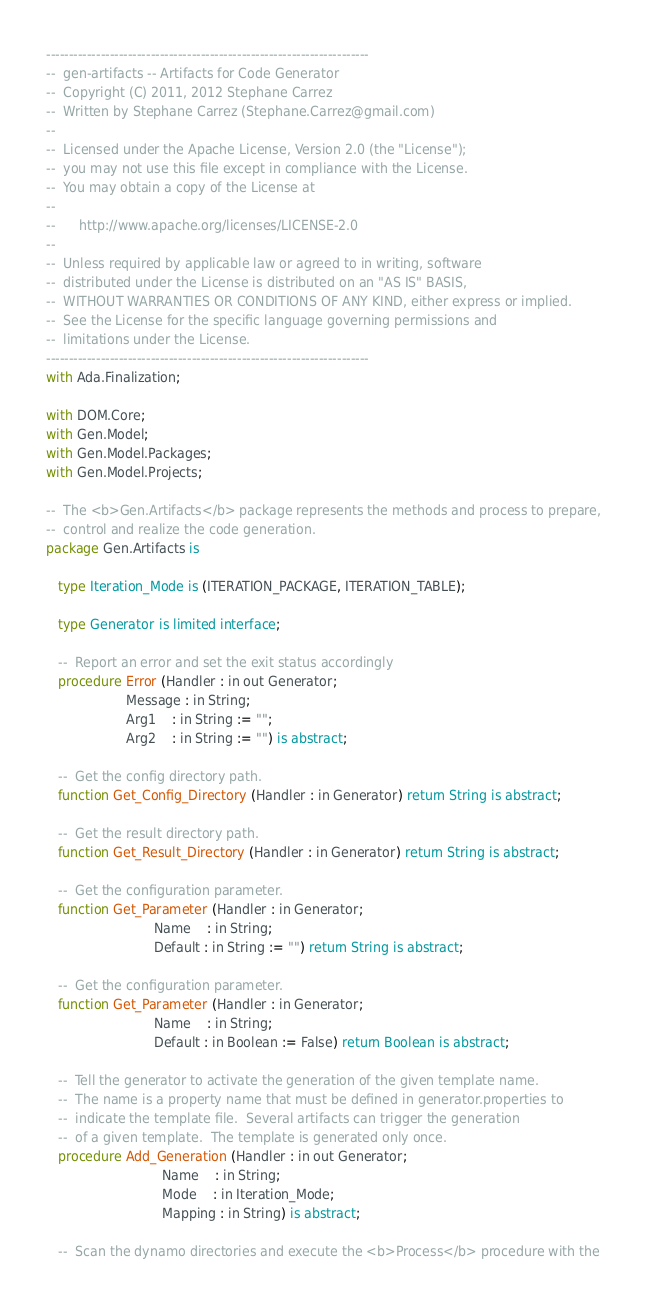<code> <loc_0><loc_0><loc_500><loc_500><_Ada_>-----------------------------------------------------------------------
--  gen-artifacts -- Artifacts for Code Generator
--  Copyright (C) 2011, 2012 Stephane Carrez
--  Written by Stephane Carrez (Stephane.Carrez@gmail.com)
--
--  Licensed under the Apache License, Version 2.0 (the "License");
--  you may not use this file except in compliance with the License.
--  You may obtain a copy of the License at
--
--      http://www.apache.org/licenses/LICENSE-2.0
--
--  Unless required by applicable law or agreed to in writing, software
--  distributed under the License is distributed on an "AS IS" BASIS,
--  WITHOUT WARRANTIES OR CONDITIONS OF ANY KIND, either express or implied.
--  See the License for the specific language governing permissions and
--  limitations under the License.
-----------------------------------------------------------------------
with Ada.Finalization;

with DOM.Core;
with Gen.Model;
with Gen.Model.Packages;
with Gen.Model.Projects;

--  The <b>Gen.Artifacts</b> package represents the methods and process to prepare,
--  control and realize the code generation.
package Gen.Artifacts is

   type Iteration_Mode is (ITERATION_PACKAGE, ITERATION_TABLE);

   type Generator is limited interface;

   --  Report an error and set the exit status accordingly
   procedure Error (Handler : in out Generator;
                    Message : in String;
                    Arg1    : in String := "";
                    Arg2    : in String := "") is abstract;

   --  Get the config directory path.
   function Get_Config_Directory (Handler : in Generator) return String is abstract;

   --  Get the result directory path.
   function Get_Result_Directory (Handler : in Generator) return String is abstract;

   --  Get the configuration parameter.
   function Get_Parameter (Handler : in Generator;
                           Name    : in String;
                           Default : in String := "") return String is abstract;

   --  Get the configuration parameter.
   function Get_Parameter (Handler : in Generator;
                           Name    : in String;
                           Default : in Boolean := False) return Boolean is abstract;

   --  Tell the generator to activate the generation of the given template name.
   --  The name is a property name that must be defined in generator.properties to
   --  indicate the template file.  Several artifacts can trigger the generation
   --  of a given template.  The template is generated only once.
   procedure Add_Generation (Handler : in out Generator;
                             Name    : in String;
                             Mode    : in Iteration_Mode;
                             Mapping : in String) is abstract;

   --  Scan the dynamo directories and execute the <b>Process</b> procedure with the</code> 